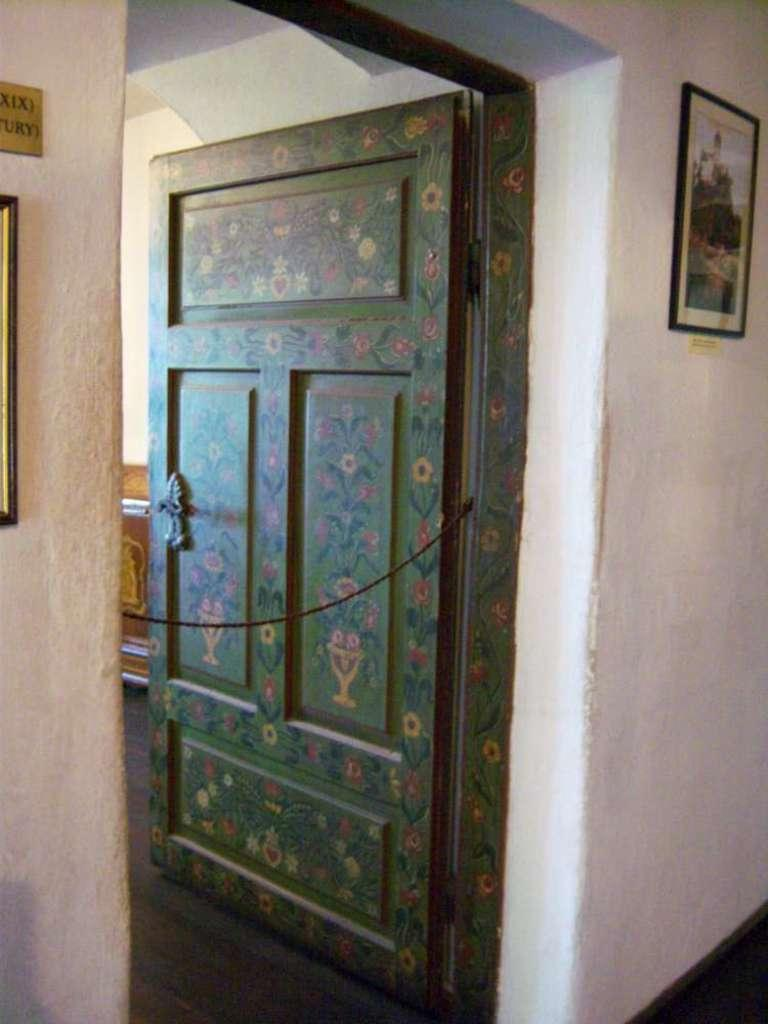What is the main subject in the center of the image? There is a door in the center of the image. What can be seen on the wall in the image? There are frames placed on the wall. Can you describe the background of the image? There is an object in the background of the image. What time of day is it in the image, and is the writer present? The time of day cannot be determined from the image, and there is no mention of a writer in the provided facts. 